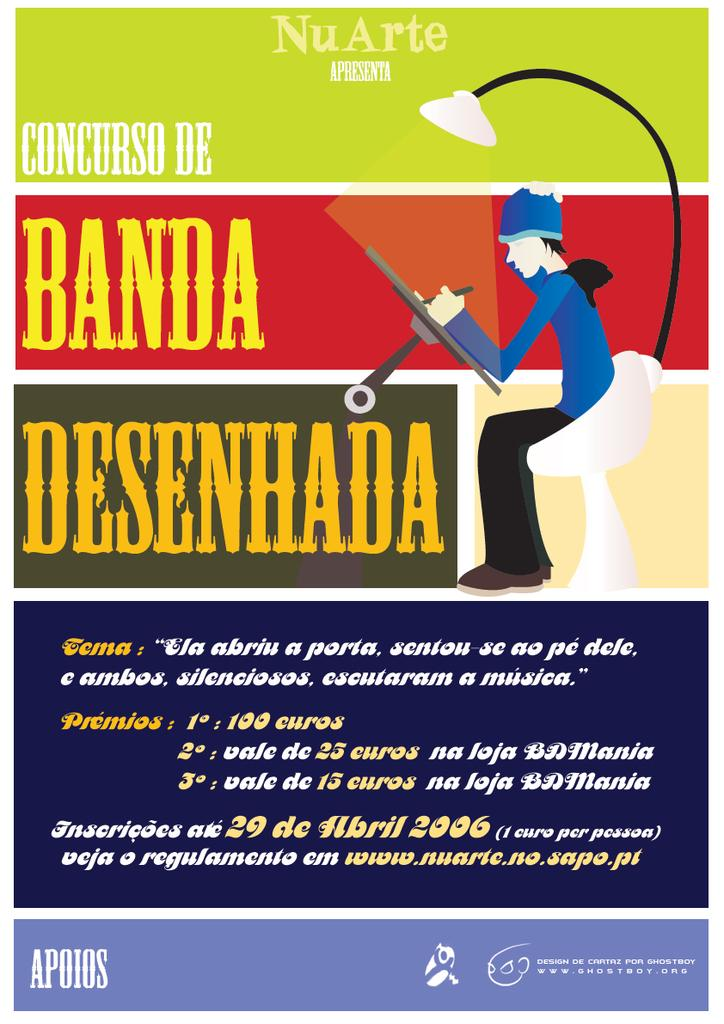What can be found on the poster in the image? There is text and images on the poster. Can you describe the text on the poster? Unfortunately, the specific content of the text cannot be determined from the image alone. What types of images are present on the poster? The images on the poster cannot be described in detail without more information. How often does the cannon fire in the image? There is no cannon present in the image. What song is being sung in the image? There is no indication of any singing or music in the image. 